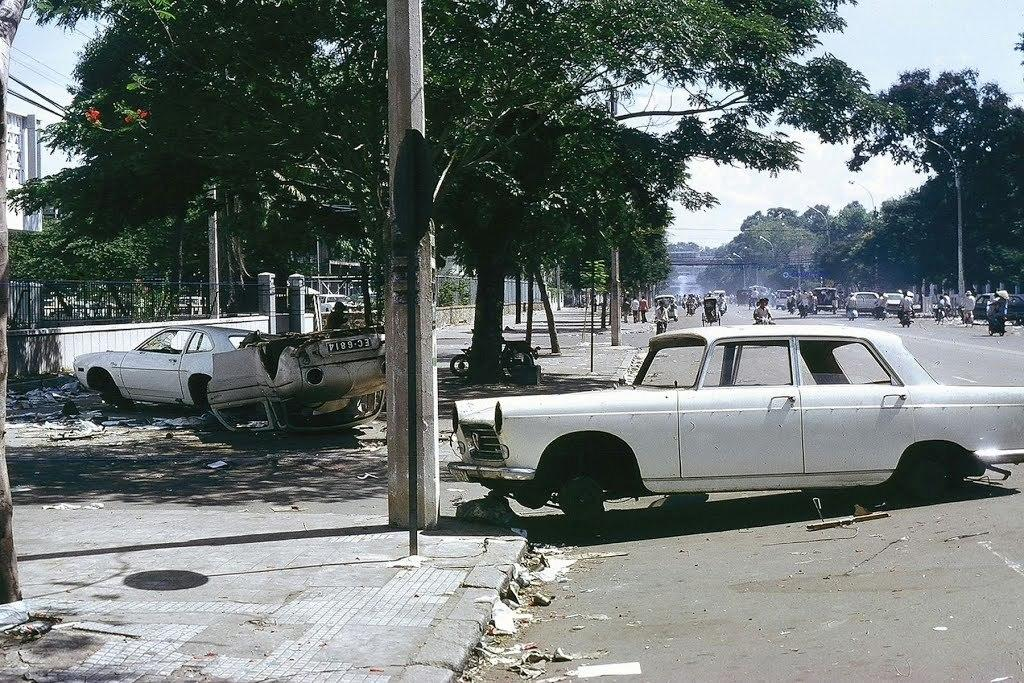What can be seen on the road in the image? There are vehicles on the road in the image. What is located on the left side of the image? There are trees, poles, a wall, and a fence on the left side of the image. What is visible in the background of the image? The sky is visible in the background of the image. What type of shock can be seen on the faces of the people in the image? There are no people present in the image, so it is not possible to determine if they are experiencing any shock. What is causing the anger in the image? There is no indication of anger in the image, as it primarily features vehicles, trees, poles, a wall, a fence, and the sky. 